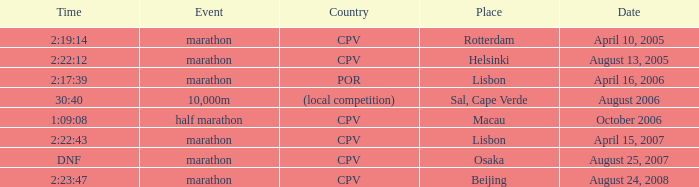What is the Date of the Event with a Time of 2:23:47? August 24, 2008. 